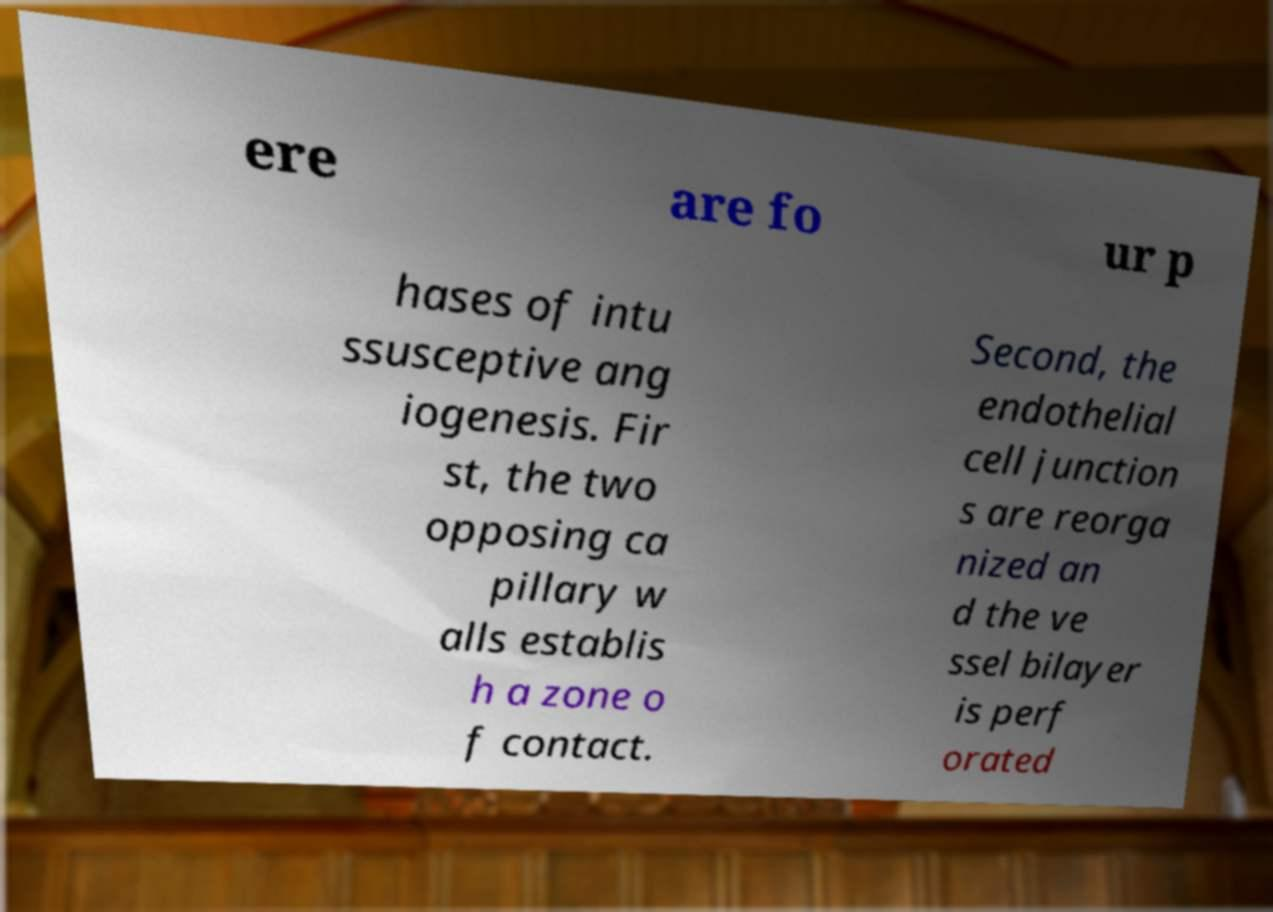Please read and relay the text visible in this image. What does it say? ere are fo ur p hases of intu ssusceptive ang iogenesis. Fir st, the two opposing ca pillary w alls establis h a zone o f contact. Second, the endothelial cell junction s are reorga nized an d the ve ssel bilayer is perf orated 